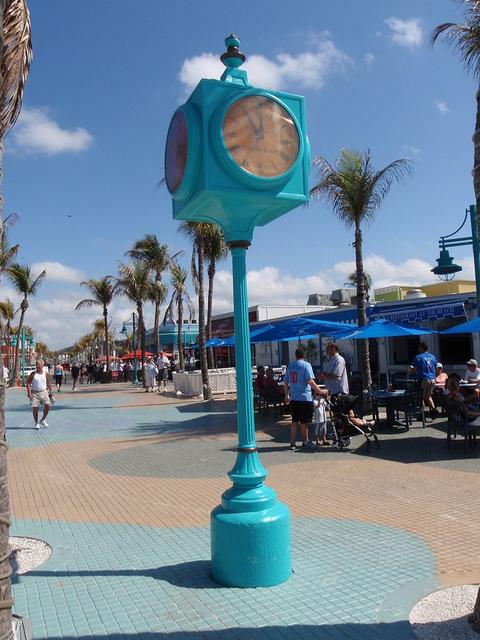What kind of trees are next to the clock?
Give a very brief answer. Palm. What color is the clock?
Keep it brief. Blue. Is it sunny?
Be succinct. Yes. Is this a busy day at the beach?
Short answer required. Yes. 